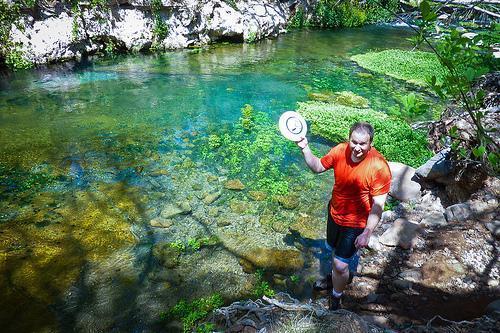How many people are in the picture?
Give a very brief answer. 1. 